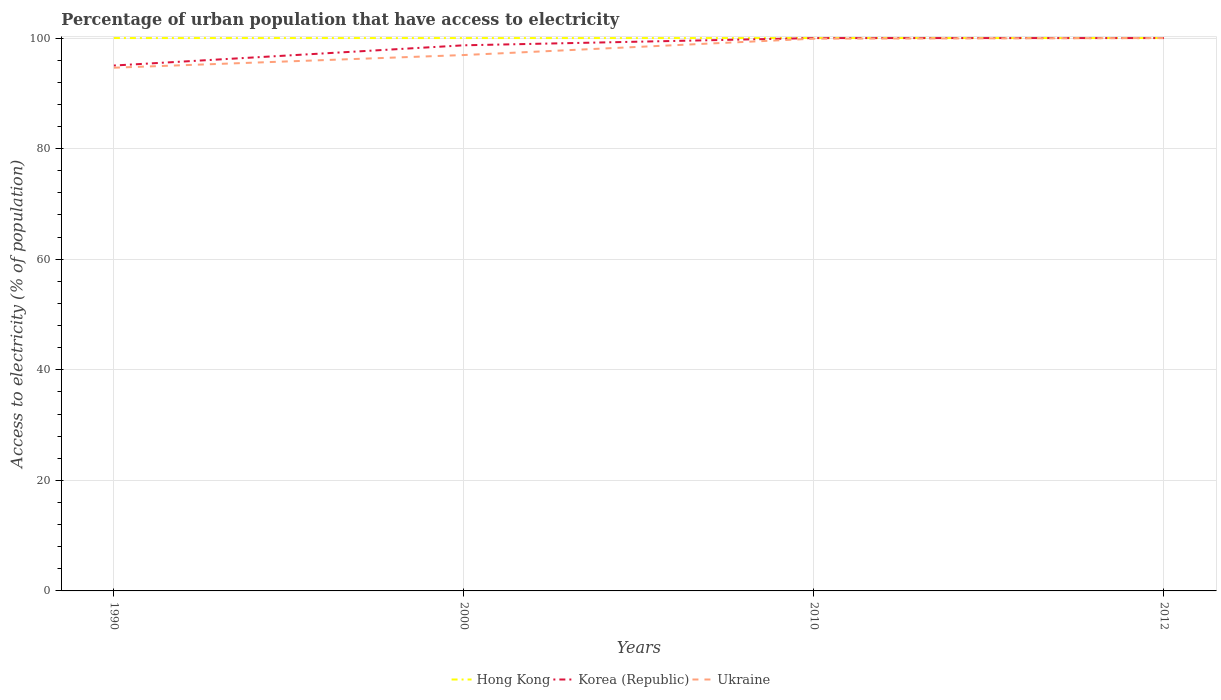Across all years, what is the maximum percentage of urban population that have access to electricity in Ukraine?
Your response must be concise. 94.64. What is the total percentage of urban population that have access to electricity in Hong Kong in the graph?
Offer a terse response. 0. Does the graph contain grids?
Provide a short and direct response. Yes. What is the title of the graph?
Ensure brevity in your answer.  Percentage of urban population that have access to electricity. Does "Germany" appear as one of the legend labels in the graph?
Give a very brief answer. No. What is the label or title of the Y-axis?
Make the answer very short. Access to electricity (% of population). What is the Access to electricity (% of population) of Hong Kong in 1990?
Give a very brief answer. 100. What is the Access to electricity (% of population) of Korea (Republic) in 1990?
Provide a short and direct response. 95.03. What is the Access to electricity (% of population) of Ukraine in 1990?
Give a very brief answer. 94.64. What is the Access to electricity (% of population) of Hong Kong in 2000?
Give a very brief answer. 100. What is the Access to electricity (% of population) in Korea (Republic) in 2000?
Make the answer very short. 98.69. What is the Access to electricity (% of population) in Ukraine in 2000?
Your response must be concise. 96.93. What is the Access to electricity (% of population) in Ukraine in 2010?
Keep it short and to the point. 99.89. What is the Access to electricity (% of population) of Hong Kong in 2012?
Provide a succinct answer. 100. What is the Access to electricity (% of population) of Korea (Republic) in 2012?
Your answer should be very brief. 100. What is the Access to electricity (% of population) in Ukraine in 2012?
Your response must be concise. 100. Across all years, what is the maximum Access to electricity (% of population) of Ukraine?
Provide a succinct answer. 100. Across all years, what is the minimum Access to electricity (% of population) of Korea (Republic)?
Your answer should be very brief. 95.03. Across all years, what is the minimum Access to electricity (% of population) of Ukraine?
Provide a succinct answer. 94.64. What is the total Access to electricity (% of population) in Korea (Republic) in the graph?
Your answer should be very brief. 393.72. What is the total Access to electricity (% of population) in Ukraine in the graph?
Make the answer very short. 391.46. What is the difference between the Access to electricity (% of population) in Hong Kong in 1990 and that in 2000?
Keep it short and to the point. 0. What is the difference between the Access to electricity (% of population) of Korea (Republic) in 1990 and that in 2000?
Provide a succinct answer. -3.66. What is the difference between the Access to electricity (% of population) in Ukraine in 1990 and that in 2000?
Your answer should be compact. -2.29. What is the difference between the Access to electricity (% of population) in Hong Kong in 1990 and that in 2010?
Ensure brevity in your answer.  0. What is the difference between the Access to electricity (% of population) in Korea (Republic) in 1990 and that in 2010?
Your answer should be compact. -4.97. What is the difference between the Access to electricity (% of population) in Ukraine in 1990 and that in 2010?
Offer a very short reply. -5.25. What is the difference between the Access to electricity (% of population) of Korea (Republic) in 1990 and that in 2012?
Provide a succinct answer. -4.97. What is the difference between the Access to electricity (% of population) of Ukraine in 1990 and that in 2012?
Your response must be concise. -5.36. What is the difference between the Access to electricity (% of population) in Hong Kong in 2000 and that in 2010?
Your answer should be compact. 0. What is the difference between the Access to electricity (% of population) of Korea (Republic) in 2000 and that in 2010?
Your answer should be compact. -1.31. What is the difference between the Access to electricity (% of population) of Ukraine in 2000 and that in 2010?
Your response must be concise. -2.96. What is the difference between the Access to electricity (% of population) of Korea (Republic) in 2000 and that in 2012?
Your answer should be very brief. -1.31. What is the difference between the Access to electricity (% of population) of Ukraine in 2000 and that in 2012?
Give a very brief answer. -3.07. What is the difference between the Access to electricity (% of population) of Hong Kong in 2010 and that in 2012?
Make the answer very short. 0. What is the difference between the Access to electricity (% of population) in Korea (Republic) in 2010 and that in 2012?
Provide a short and direct response. 0. What is the difference between the Access to electricity (% of population) of Ukraine in 2010 and that in 2012?
Your answer should be compact. -0.11. What is the difference between the Access to electricity (% of population) of Hong Kong in 1990 and the Access to electricity (% of population) of Korea (Republic) in 2000?
Keep it short and to the point. 1.31. What is the difference between the Access to electricity (% of population) in Hong Kong in 1990 and the Access to electricity (% of population) in Ukraine in 2000?
Offer a terse response. 3.07. What is the difference between the Access to electricity (% of population) in Korea (Republic) in 1990 and the Access to electricity (% of population) in Ukraine in 2000?
Offer a very short reply. -1.9. What is the difference between the Access to electricity (% of population) in Hong Kong in 1990 and the Access to electricity (% of population) in Korea (Republic) in 2010?
Provide a short and direct response. 0. What is the difference between the Access to electricity (% of population) of Hong Kong in 1990 and the Access to electricity (% of population) of Ukraine in 2010?
Give a very brief answer. 0.11. What is the difference between the Access to electricity (% of population) in Korea (Republic) in 1990 and the Access to electricity (% of population) in Ukraine in 2010?
Make the answer very short. -4.86. What is the difference between the Access to electricity (% of population) in Korea (Republic) in 1990 and the Access to electricity (% of population) in Ukraine in 2012?
Make the answer very short. -4.97. What is the difference between the Access to electricity (% of population) of Hong Kong in 2000 and the Access to electricity (% of population) of Korea (Republic) in 2010?
Make the answer very short. 0. What is the difference between the Access to electricity (% of population) of Hong Kong in 2000 and the Access to electricity (% of population) of Ukraine in 2010?
Give a very brief answer. 0.11. What is the difference between the Access to electricity (% of population) of Korea (Republic) in 2000 and the Access to electricity (% of population) of Ukraine in 2010?
Ensure brevity in your answer.  -1.2. What is the difference between the Access to electricity (% of population) in Hong Kong in 2000 and the Access to electricity (% of population) in Ukraine in 2012?
Your response must be concise. 0. What is the difference between the Access to electricity (% of population) of Korea (Republic) in 2000 and the Access to electricity (% of population) of Ukraine in 2012?
Your answer should be very brief. -1.31. What is the difference between the Access to electricity (% of population) in Hong Kong in 2010 and the Access to electricity (% of population) in Korea (Republic) in 2012?
Offer a terse response. 0. What is the difference between the Access to electricity (% of population) of Hong Kong in 2010 and the Access to electricity (% of population) of Ukraine in 2012?
Your response must be concise. 0. What is the difference between the Access to electricity (% of population) of Korea (Republic) in 2010 and the Access to electricity (% of population) of Ukraine in 2012?
Provide a succinct answer. 0. What is the average Access to electricity (% of population) of Korea (Republic) per year?
Your answer should be compact. 98.43. What is the average Access to electricity (% of population) of Ukraine per year?
Provide a succinct answer. 97.86. In the year 1990, what is the difference between the Access to electricity (% of population) of Hong Kong and Access to electricity (% of population) of Korea (Republic)?
Keep it short and to the point. 4.97. In the year 1990, what is the difference between the Access to electricity (% of population) in Hong Kong and Access to electricity (% of population) in Ukraine?
Give a very brief answer. 5.36. In the year 1990, what is the difference between the Access to electricity (% of population) in Korea (Republic) and Access to electricity (% of population) in Ukraine?
Your response must be concise. 0.39. In the year 2000, what is the difference between the Access to electricity (% of population) of Hong Kong and Access to electricity (% of population) of Korea (Republic)?
Provide a short and direct response. 1.31. In the year 2000, what is the difference between the Access to electricity (% of population) of Hong Kong and Access to electricity (% of population) of Ukraine?
Ensure brevity in your answer.  3.07. In the year 2000, what is the difference between the Access to electricity (% of population) in Korea (Republic) and Access to electricity (% of population) in Ukraine?
Your answer should be compact. 1.76. In the year 2010, what is the difference between the Access to electricity (% of population) of Hong Kong and Access to electricity (% of population) of Korea (Republic)?
Your response must be concise. 0. In the year 2010, what is the difference between the Access to electricity (% of population) of Hong Kong and Access to electricity (% of population) of Ukraine?
Your answer should be very brief. 0.11. In the year 2010, what is the difference between the Access to electricity (% of population) of Korea (Republic) and Access to electricity (% of population) of Ukraine?
Your answer should be compact. 0.11. In the year 2012, what is the difference between the Access to electricity (% of population) in Hong Kong and Access to electricity (% of population) in Korea (Republic)?
Your answer should be compact. 0. In the year 2012, what is the difference between the Access to electricity (% of population) in Hong Kong and Access to electricity (% of population) in Ukraine?
Give a very brief answer. 0. What is the ratio of the Access to electricity (% of population) in Hong Kong in 1990 to that in 2000?
Give a very brief answer. 1. What is the ratio of the Access to electricity (% of population) of Korea (Republic) in 1990 to that in 2000?
Your response must be concise. 0.96. What is the ratio of the Access to electricity (% of population) in Ukraine in 1990 to that in 2000?
Your answer should be very brief. 0.98. What is the ratio of the Access to electricity (% of population) of Korea (Republic) in 1990 to that in 2010?
Offer a very short reply. 0.95. What is the ratio of the Access to electricity (% of population) in Ukraine in 1990 to that in 2010?
Provide a short and direct response. 0.95. What is the ratio of the Access to electricity (% of population) of Hong Kong in 1990 to that in 2012?
Offer a terse response. 1. What is the ratio of the Access to electricity (% of population) of Korea (Republic) in 1990 to that in 2012?
Make the answer very short. 0.95. What is the ratio of the Access to electricity (% of population) in Ukraine in 1990 to that in 2012?
Keep it short and to the point. 0.95. What is the ratio of the Access to electricity (% of population) of Hong Kong in 2000 to that in 2010?
Give a very brief answer. 1. What is the ratio of the Access to electricity (% of population) in Korea (Republic) in 2000 to that in 2010?
Make the answer very short. 0.99. What is the ratio of the Access to electricity (% of population) in Ukraine in 2000 to that in 2010?
Make the answer very short. 0.97. What is the ratio of the Access to electricity (% of population) in Korea (Republic) in 2000 to that in 2012?
Give a very brief answer. 0.99. What is the ratio of the Access to electricity (% of population) in Ukraine in 2000 to that in 2012?
Provide a succinct answer. 0.97. What is the ratio of the Access to electricity (% of population) in Korea (Republic) in 2010 to that in 2012?
Your response must be concise. 1. What is the difference between the highest and the second highest Access to electricity (% of population) in Hong Kong?
Your answer should be compact. 0. What is the difference between the highest and the second highest Access to electricity (% of population) in Korea (Republic)?
Provide a succinct answer. 0. What is the difference between the highest and the second highest Access to electricity (% of population) in Ukraine?
Give a very brief answer. 0.11. What is the difference between the highest and the lowest Access to electricity (% of population) in Korea (Republic)?
Offer a very short reply. 4.97. What is the difference between the highest and the lowest Access to electricity (% of population) of Ukraine?
Your answer should be very brief. 5.36. 